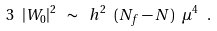Convert formula to latex. <formula><loc_0><loc_0><loc_500><loc_500>3 \ | W _ { 0 } | ^ { 2 } \ \sim \ h ^ { 2 } \ ( N _ { f } - N ) \ \mu ^ { 4 } \ .</formula> 